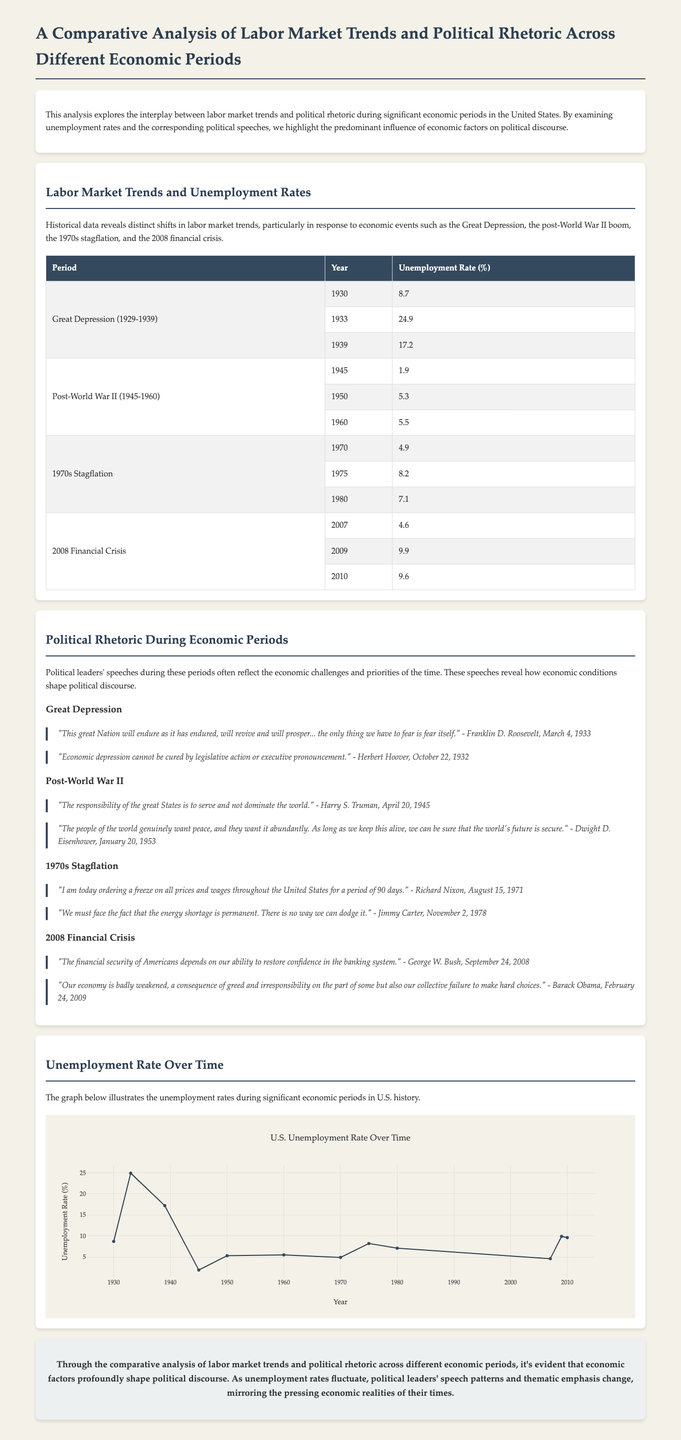What was the unemployment rate in 1933? The unemployment rate in 1933 during the Great Depression was 24.9%.
Answer: 24.9 Which president made the quote about fear during the Great Depression? Franklin D. Roosevelt made the quote about fear on March 4, 1933.
Answer: Franklin D. Roosevelt What year had the highest unemployment rate listed in the document? The year 1933 had the highest unemployment rate listed in the document at 24.9%.
Answer: 1933 What is the unemployment rate in 1945? The unemployment rate in 1945, during the Post-World War II period, was 1.9%.
Answer: 1.9 Which economic period experienced stagflation? The 1970s experienced stagflation, as mentioned in the document.
Answer: 1970s What is the title of the analysis? The title of the analysis is "A Comparative Analysis of Labor Market Trends and Political Rhetoric Across Different Economic Periods."
Answer: A Comparative Analysis of Labor Market Trends and Political Rhetoric Across Different Economic Periods What is the main conclusion drawn in the document? The conclusion highlights that economic factors profoundly shape political discourse over time.
Answer: Economic factors profoundly shape political discourse How many periods of economic analysis are mentioned in the document? There are four periods of economic analysis mentioned: Great Depression, Post-World War II, 1970s Stagflation, and 2008 Financial Crisis.
Answer: Four periods 